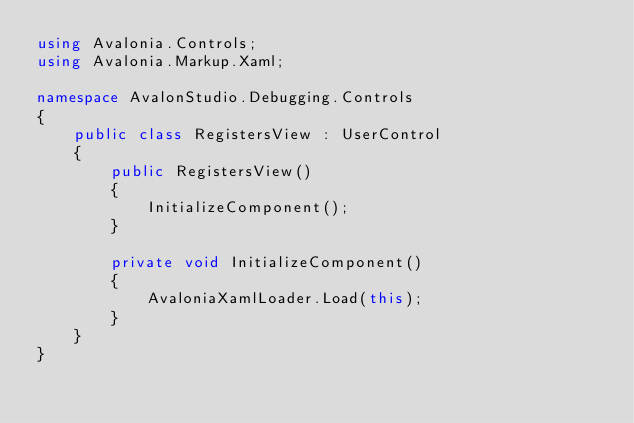<code> <loc_0><loc_0><loc_500><loc_500><_C#_>using Avalonia.Controls;
using Avalonia.Markup.Xaml;

namespace AvalonStudio.Debugging.Controls
{
    public class RegistersView : UserControl
    {
        public RegistersView()
        {
            InitializeComponent();
        }

        private void InitializeComponent()
        {
            AvaloniaXamlLoader.Load(this);
        }
    }
}</code> 